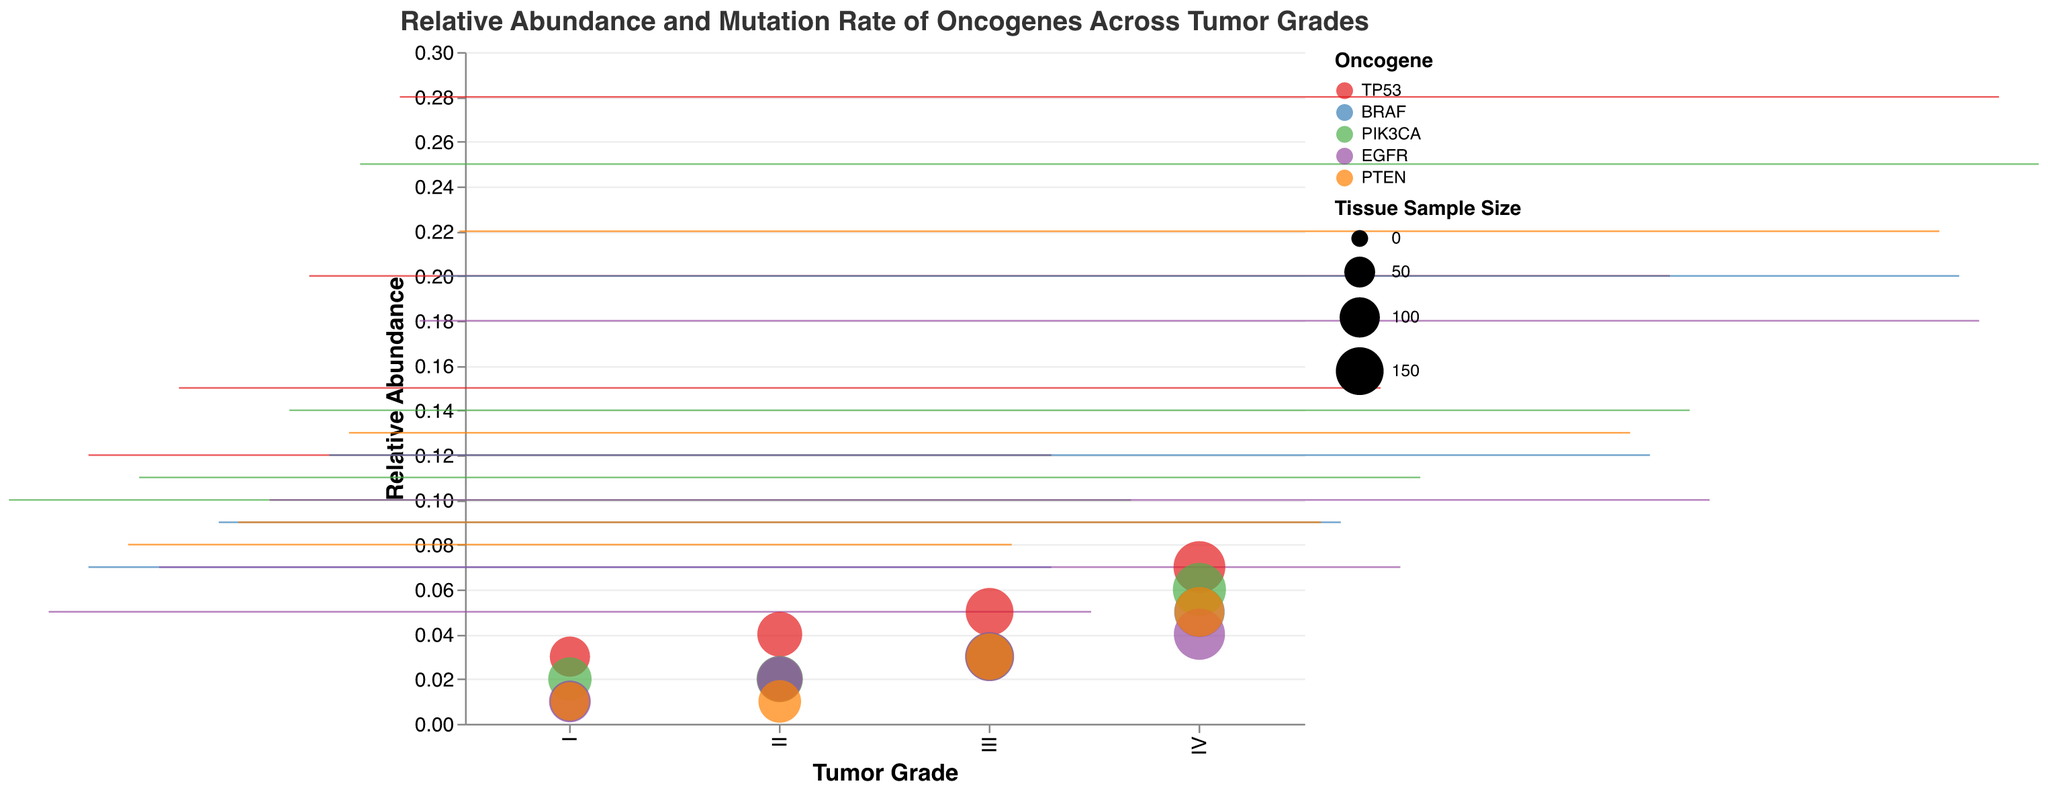What is the title of the plot? The title is displayed prominently at the top of the figure, indicating what the figure represents.
Answer: Relative Abundance and Mutation Rate of Oncogenes Across Tumor Grades How many oncogenes are represented in the plot? Five oncogenes are indicated in the color legend. Each oncogene is represented by a different color.
Answer: 5 Which tumor grade has the highest relative abundance of the oncogene TP53? By looking at the heights of the box plots for TP53 across different tumor grades, the highest average relative abundance of TP53 is in Grade IV.
Answer: IV What does the size of the point represent in this figure? The size of the points is based on the Tissue Sample Size, with larger points indicating larger sample sizes.
Answer: Tissue Sample Size Among all the oncogenes listed, which shows the highest relative abundance in tumor grade III? By inspecting the height of the box plots for tumor grade III, the oncogene TP53 shows the highest relative abundance.
Answer: TP53 What is the mutation rate of PIK3CA in tumor grade I? The small point plotted for PIK3CA in tumor grade I shows its mutation rate.
Answer: 0.02 How does the mutation rate of EGFR compare between tumor grades II and III? By examining the position of the points for EGFR in grades II and III, the mutation rate is the same for both grades at 0.02 and 0.03, respectively.
Answer: Grade III has a higher mutation rate than Grade II What is the range of relative abundance for BRAF across all tumor grades? By looking at the extents of the box plots for BRAF in each tumor grade, the minimum and maximum relative abundance values can be determined. It ranges from approximately 0.07 to 0.20.
Answer: 0.07 to 0.20 Which oncogene has the maximum relative abundance in the highest tumor grade (IV)? The highest box plot within tumor grade IV indicates that TP53 has the maximum relative abundance.
Answer: TP53 Compare the relative abundance of PTEN in tumor grades I and IV. By checking the box plots for PTEN in grades I and IV, PTEN has a higher relative abundance in grade IV than in grade I.
Answer: Grade IV has higher relative abundance 